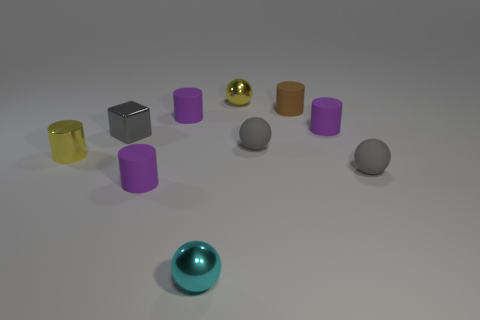How many things are either tiny purple cylinders that are on the right side of the tiny cyan metallic thing or brown shiny objects?
Ensure brevity in your answer.  1. Are there fewer gray things than small spheres?
Your response must be concise. Yes. The metallic thing to the right of the cyan shiny sphere that is to the left of the tiny purple rubber cylinder that is right of the brown object is what shape?
Ensure brevity in your answer.  Sphere. There is a small thing that is the same color as the metallic cylinder; what shape is it?
Provide a succinct answer. Sphere. Is there a large cyan metal sphere?
Your response must be concise. No. There is a gray thing that is to the left of the yellow shiny sphere; is there a tiny brown object behind it?
Provide a succinct answer. Yes. The tiny ball that is on the left side of the small brown matte cylinder and in front of the metal cylinder is made of what material?
Your response must be concise. Metal. What color is the cylinder in front of the gray matte sphere that is in front of the small yellow object left of the shiny cube?
Keep it short and to the point. Purple. The shiny cylinder that is the same size as the shiny block is what color?
Make the answer very short. Yellow. Is the color of the block the same as the matte ball in front of the yellow cylinder?
Your response must be concise. Yes. 